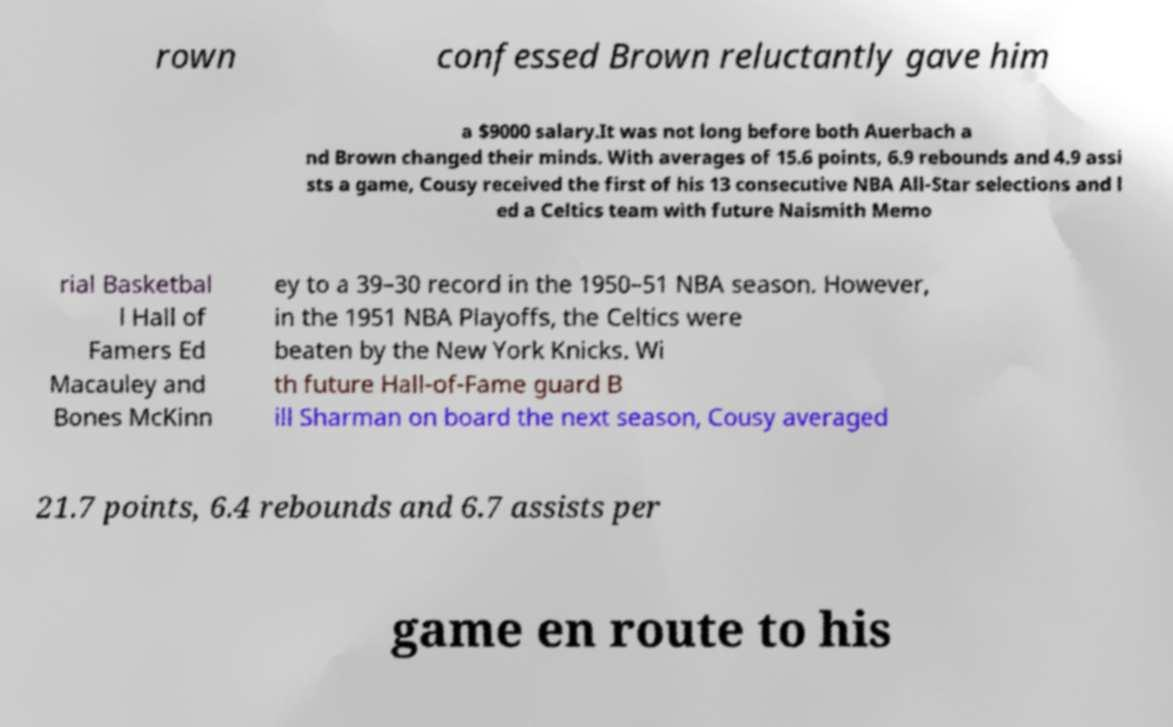Can you read and provide the text displayed in the image?This photo seems to have some interesting text. Can you extract and type it out for me? rown confessed Brown reluctantly gave him a $9000 salary.It was not long before both Auerbach a nd Brown changed their minds. With averages of 15.6 points, 6.9 rebounds and 4.9 assi sts a game, Cousy received the first of his 13 consecutive NBA All-Star selections and l ed a Celtics team with future Naismith Memo rial Basketbal l Hall of Famers Ed Macauley and Bones McKinn ey to a 39–30 record in the 1950–51 NBA season. However, in the 1951 NBA Playoffs, the Celtics were beaten by the New York Knicks. Wi th future Hall-of-Fame guard B ill Sharman on board the next season, Cousy averaged 21.7 points, 6.4 rebounds and 6.7 assists per game en route to his 